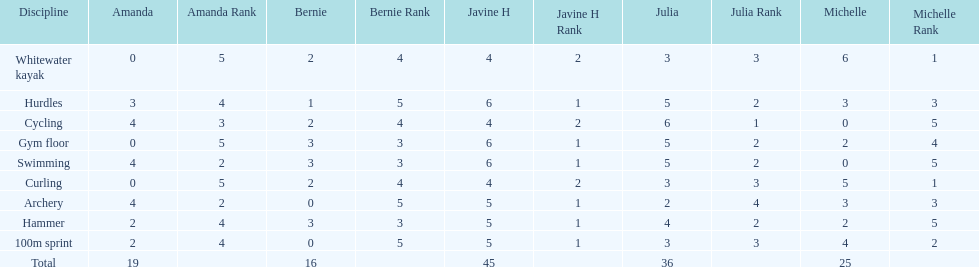Who scored the least on whitewater kayak? Amanda. 